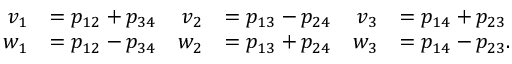Convert formula to latex. <formula><loc_0><loc_0><loc_500><loc_500>\begin{array} { r l r l r l } { v _ { 1 } } & { = p _ { 1 2 } + p _ { 3 4 } } & { v _ { 2 } } & { = p _ { 1 3 } - p _ { 2 4 } } & { v _ { 3 } } & { = p _ { 1 4 } + p _ { 2 3 } } \\ { w _ { 1 } } & { = p _ { 1 2 } - p _ { 3 4 } } & { w _ { 2 } } & { = p _ { 1 3 } + p _ { 2 4 } } & { w _ { 3 } } & { = p _ { 1 4 } - p _ { 2 3 } . } \end{array}</formula> 